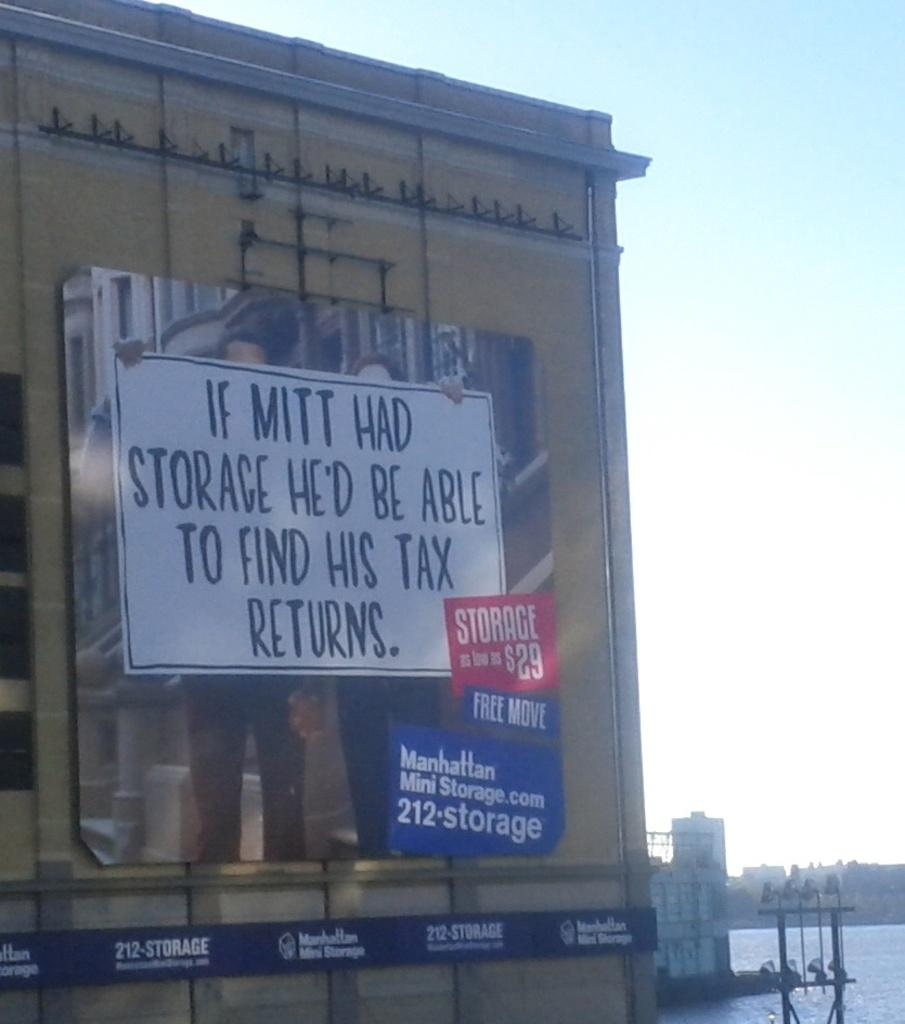Provide a one-sentence caption for the provided image. A storage advertisement claiming that if Mitt had storage he would be able to find his tax returns. 